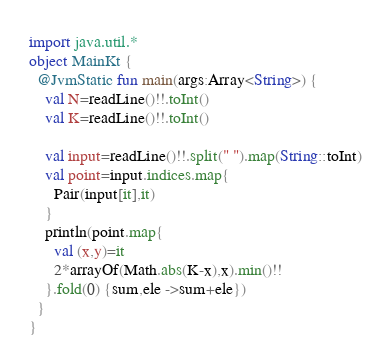<code> <loc_0><loc_0><loc_500><loc_500><_Kotlin_>import java.util.*
object MainKt {
  @JvmStatic fun main(args:Array<String>) {
    val N=readLine()!!.toInt()
    val K=readLine()!!.toInt()

    val input=readLine()!!.split(" ").map(String::toInt)
    val point=input.indices.map{
      Pair(input[it],it)
    }
    println(point.map{
      val (x,y)=it
      2*arrayOf(Math.abs(K-x),x).min()!!
    }.fold(0) {sum,ele ->sum+ele})
  }
}</code> 